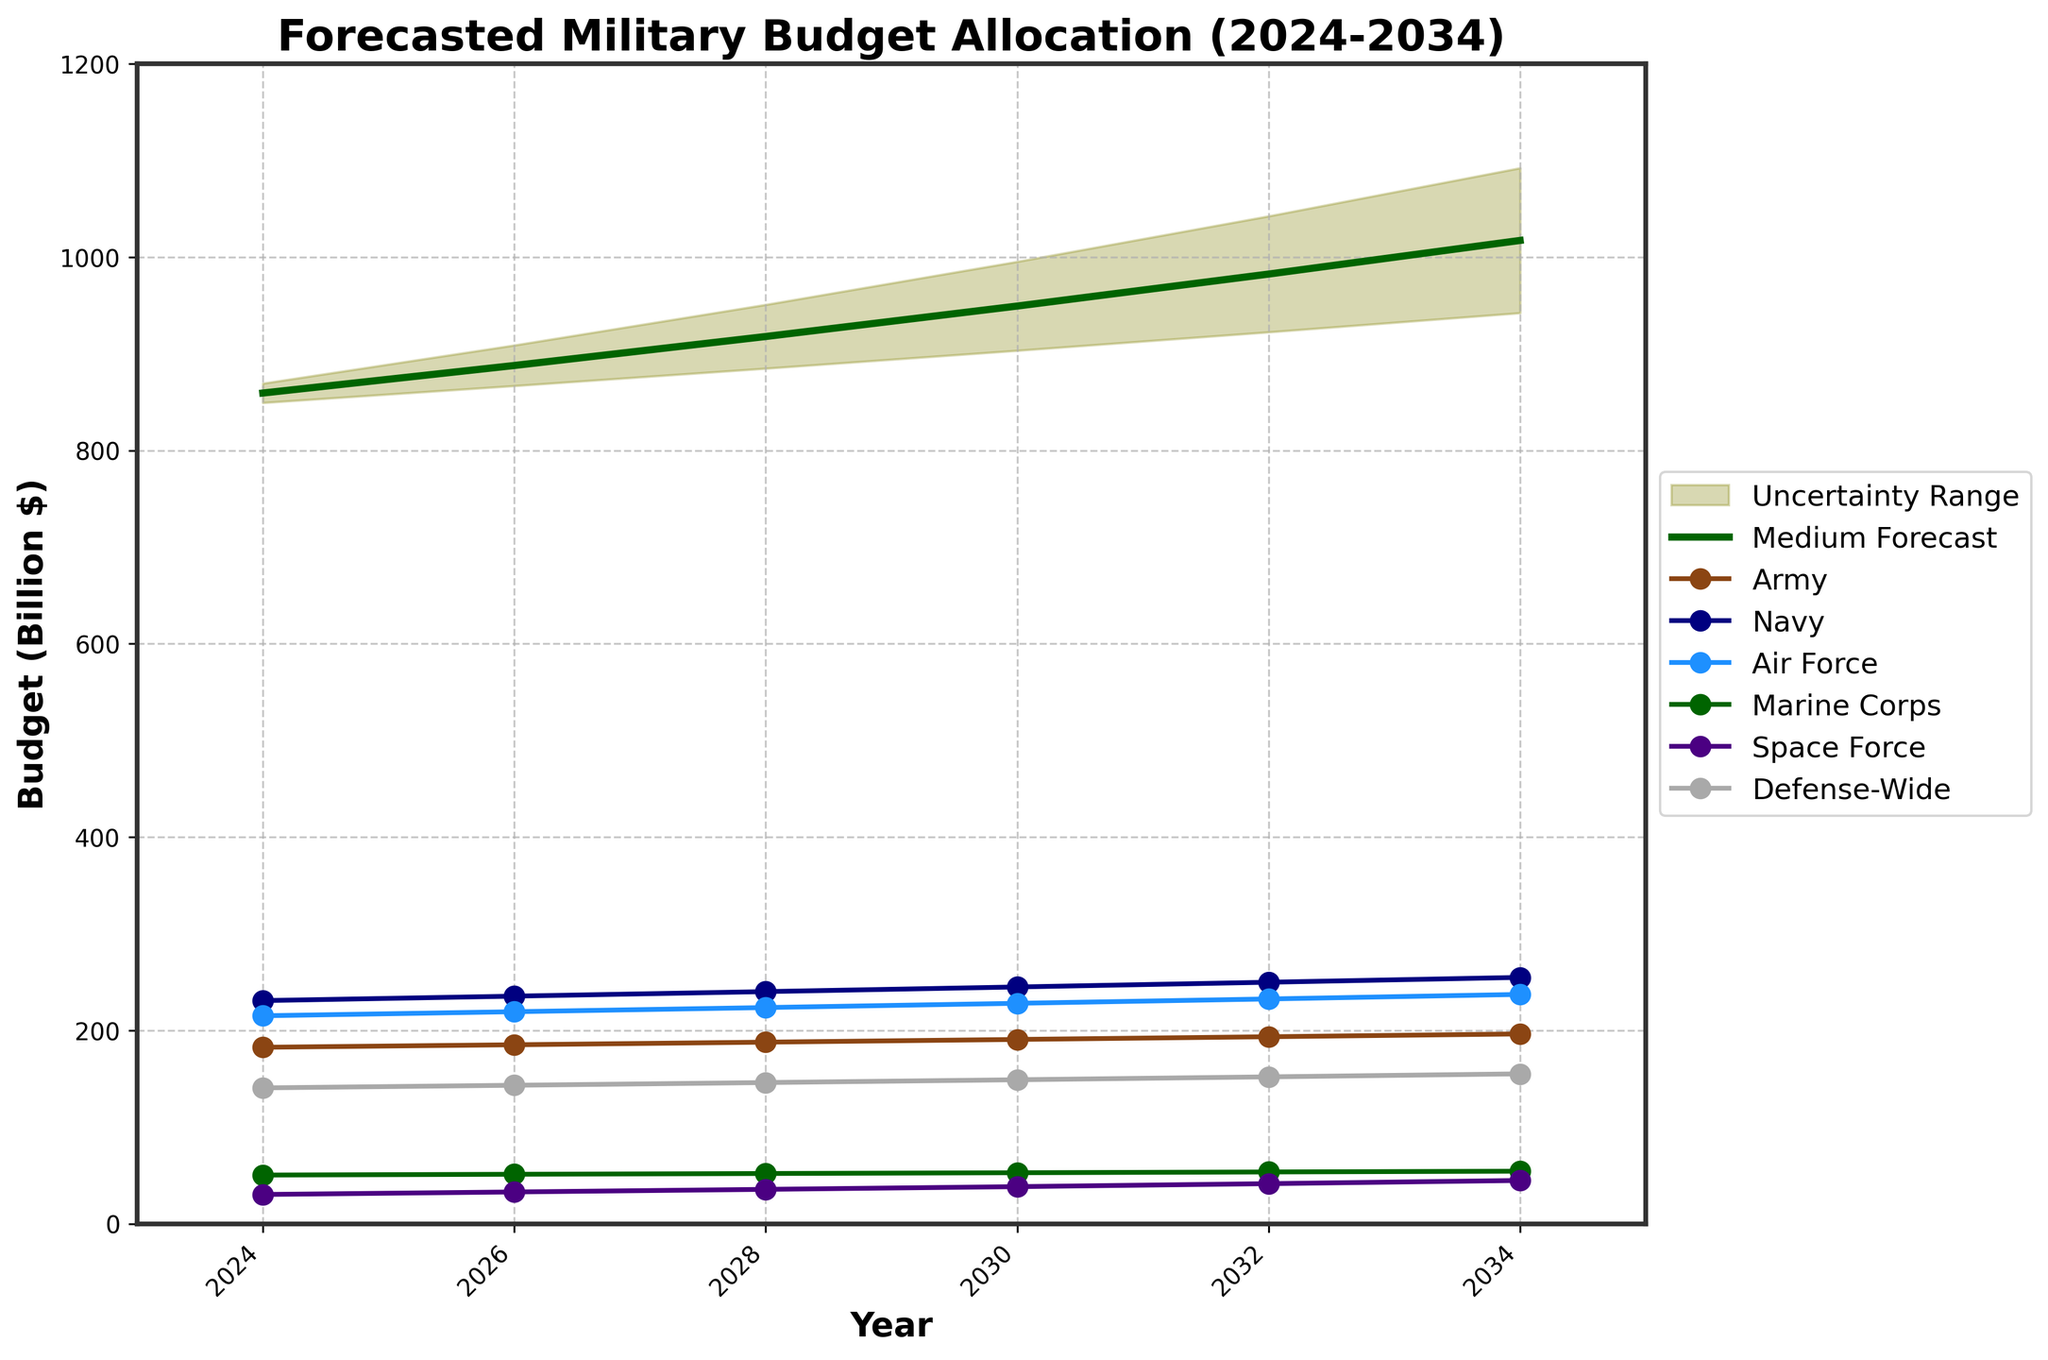How many branches of the military are there in the forecast? The figure shows different colored lines representing the budget allocations for each military branch over time. Six distinct labels are visible.
Answer: 6 What is the title of the chart? The top part of the chart provides the title, which describes the overall content of the figure.
Answer: Forecasted Military Budget Allocation (2024-2034) What is the maximum budget forecast for the year 2034 for the 'Army'? The chart has a separate line for the Army, which can be traced to the values shown in 2034.
Answer: 196.3 billion dollars In what year is the Marine Corps' budget forecast to reach approximately 54.3 billion dollars? By tracing the Marine Corps line (green) over the years, you will find that the value reaches 54.3 in the year 2034.
Answer: 2034 Which branch has the highest budget forecast for 2026? For the year 2026, each branch's budget can be compared, and the Navy has the highest value.
Answer: Navy How much does the Air Force budget increase from 2024 to 2030? From the chart, the Air Force budget increases from 215.1 in 2024 to 228.0 in 2030. Therefore, 228.0 - 215.1 = 12.9.
Answer: 12.9 billion dollars Which year has the highest medium forecast for the total military budget? The medium forecast (dark green line) can be examined over the years, with the highest value visible in the year 2034.
Answer: 2034 How does the range of uncertainty change from 2026 to 2034? The uncertainty range is indicated by the olive shaded area. In 2026, it ranges between 866.9 and 908.9; in 2034, between 942.3 and 1092.3. The range increases from 42.0 billion dollars to 150.0 billion dollars.
Answer: It increases When does the Defense-Wide budget surpass 150 billion dollars? Observing the Defense-Wide line (grey) on the chart, it surpasses 150 billion dollars by 2032.
Answer: 2032 